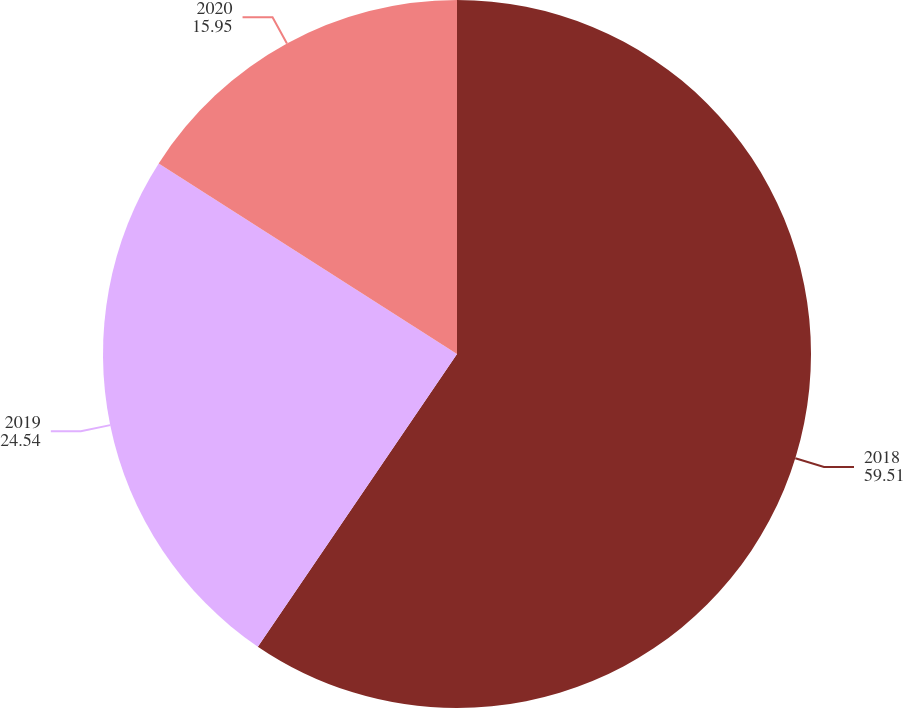Convert chart to OTSL. <chart><loc_0><loc_0><loc_500><loc_500><pie_chart><fcel>2018<fcel>2019<fcel>2020<nl><fcel>59.51%<fcel>24.54%<fcel>15.95%<nl></chart> 